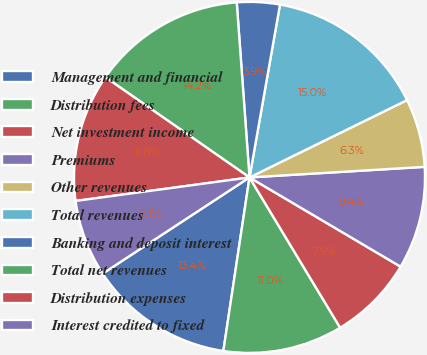Convert chart to OTSL. <chart><loc_0><loc_0><loc_500><loc_500><pie_chart><fcel>Management and financial<fcel>Distribution fees<fcel>Net investment income<fcel>Premiums<fcel>Other revenues<fcel>Total revenues<fcel>Banking and deposit interest<fcel>Total net revenues<fcel>Distribution expenses<fcel>Interest credited to fixed<nl><fcel>13.39%<fcel>11.02%<fcel>7.87%<fcel>9.45%<fcel>6.3%<fcel>14.96%<fcel>3.94%<fcel>14.17%<fcel>11.81%<fcel>7.09%<nl></chart> 